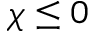Convert formula to latex. <formula><loc_0><loc_0><loc_500><loc_500>\chi \leq 0</formula> 